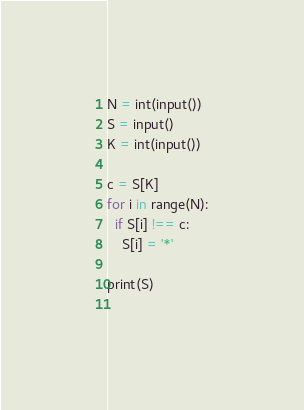Convert code to text. <code><loc_0><loc_0><loc_500><loc_500><_Python_>N = int(input())
S = input()
K = int(input())

c = S[K]
for i in range(N):
  if S[i] !== c:
    S[i] = '*'

print(S)
    </code> 